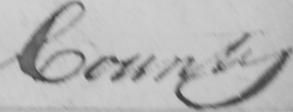Please provide the text content of this handwritten line. County 